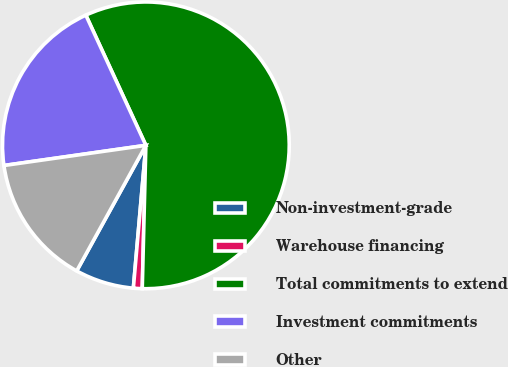<chart> <loc_0><loc_0><loc_500><loc_500><pie_chart><fcel>Non-investment-grade<fcel>Warehouse financing<fcel>Total commitments to extend<fcel>Investment commitments<fcel>Other<nl><fcel>6.62%<fcel>0.99%<fcel>57.27%<fcel>20.37%<fcel>14.74%<nl></chart> 